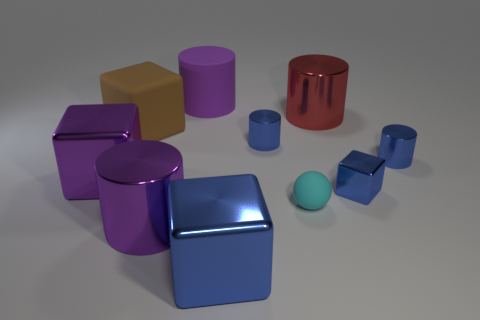There is a cylinder that is in front of the large purple cube; is it the same color as the large rubber cylinder that is on the right side of the big rubber block?
Your answer should be very brief. Yes. What number of big purple shiny objects are behind the large brown object?
Your response must be concise. 0. Are there any big brown blocks that are right of the metal cube to the left of the purple cylinder that is behind the large brown object?
Make the answer very short. Yes. What number of matte things are the same size as the cyan sphere?
Provide a short and direct response. 0. There is a blue block that is behind the big purple cylinder that is to the left of the purple matte cylinder; what is it made of?
Offer a very short reply. Metal. What is the shape of the large thing that is right of the big thing in front of the big cylinder in front of the large purple metallic block?
Your answer should be very brief. Cylinder. Is the shape of the small blue metallic object left of the tiny cube the same as the purple thing in front of the cyan object?
Keep it short and to the point. Yes. What number of other objects are there of the same material as the red cylinder?
Give a very brief answer. 6. There is a large brown thing that is the same material as the small cyan thing; what is its shape?
Provide a succinct answer. Cube. Is the red thing the same size as the cyan sphere?
Provide a short and direct response. No. 